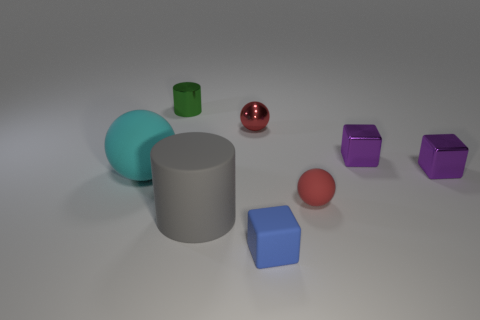Is the shape of the rubber thing that is to the left of the big gray cylinder the same as the small metal object left of the tiny red metallic thing?
Provide a succinct answer. No. How many objects are tiny purple metal cylinders or cylinders?
Offer a very short reply. 2. Are there any rubber objects?
Provide a succinct answer. Yes. Do the small red thing that is on the left side of the rubber block and the cyan sphere have the same material?
Make the answer very short. No. Are there any green metal things of the same shape as the blue rubber thing?
Your answer should be very brief. No. Are there the same number of small matte cubes that are in front of the rubber block and cyan shiny things?
Your answer should be very brief. Yes. What is the material of the tiny sphere that is on the right side of the small cube on the left side of the red matte sphere?
Provide a short and direct response. Rubber. What shape is the tiny green thing?
Your answer should be very brief. Cylinder. Are there the same number of tiny objects in front of the red rubber thing and tiny blocks that are in front of the big cyan rubber thing?
Your answer should be very brief. Yes. There is a cylinder that is on the right side of the small cylinder; does it have the same color as the small sphere left of the tiny matte block?
Your answer should be compact. No. 